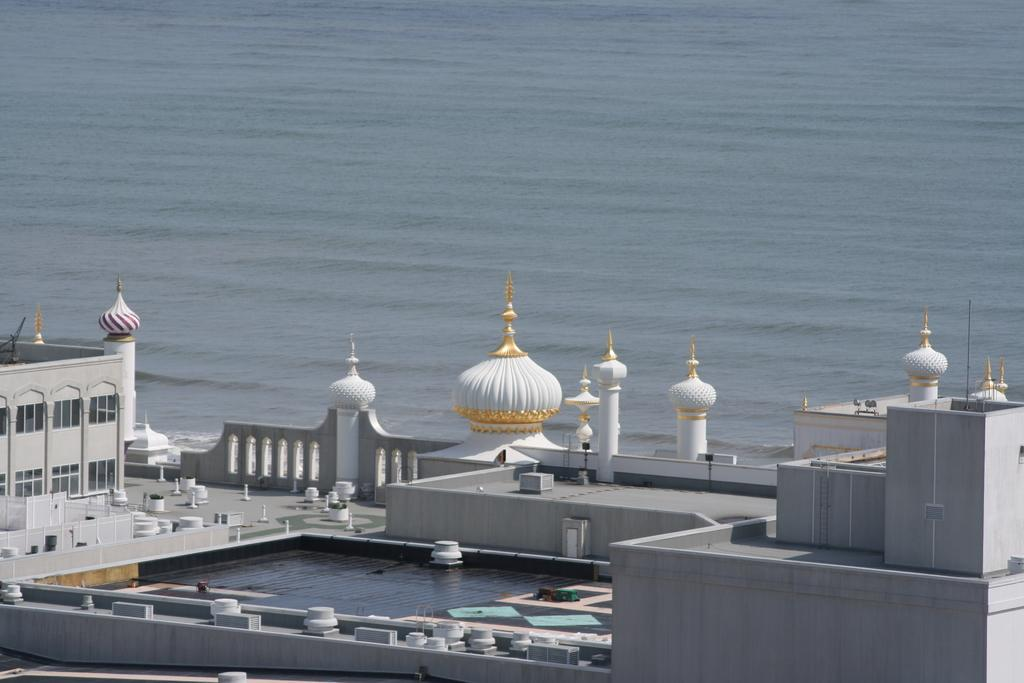What type of building is visible in the image? There is a mosque in the image. Can you describe the location of the mosque in the image? The mosque is floating on the water surface. What word is being used to describe the temper of the bat in the image? There is no bat or word about its temper in the image; it only features a mosque floating on the water surface. 